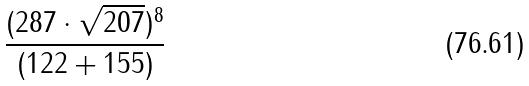<formula> <loc_0><loc_0><loc_500><loc_500>\frac { ( 2 8 7 \cdot \sqrt { 2 0 7 } ) ^ { 8 } } { ( 1 2 2 + 1 5 5 ) }</formula> 